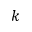Convert formula to latex. <formula><loc_0><loc_0><loc_500><loc_500>k</formula> 